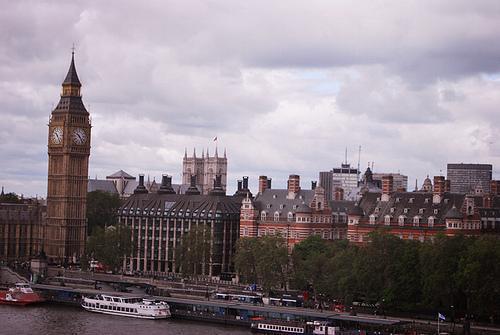How many planes are in the sky?
Give a very brief answer. 0. 